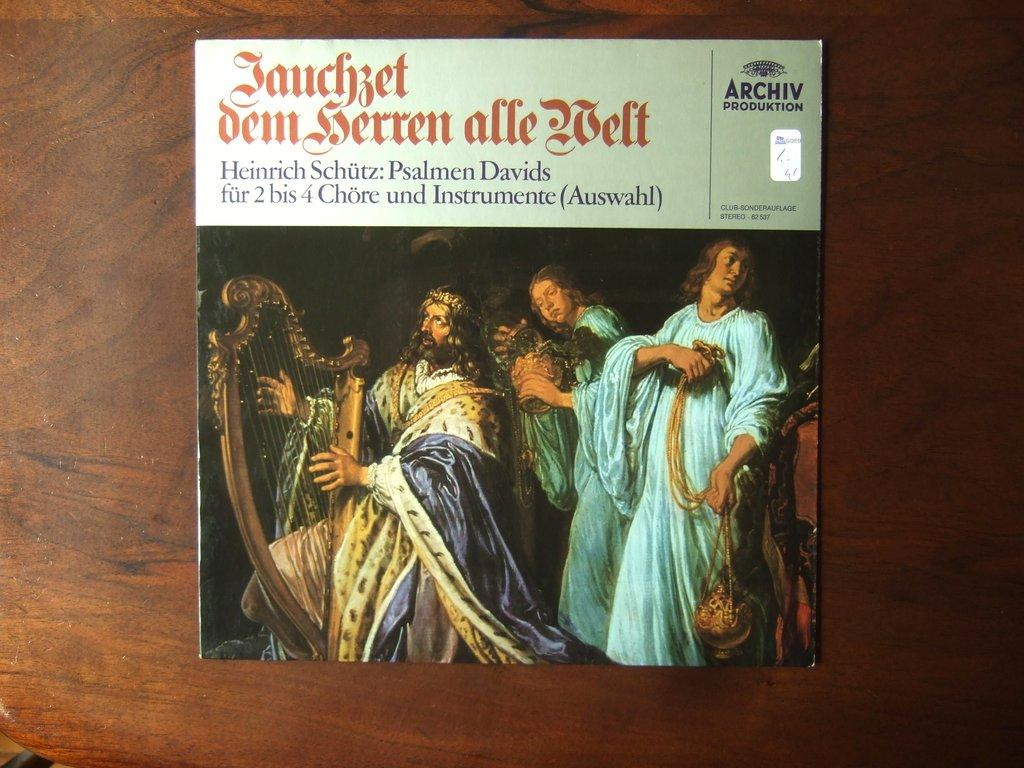What can be seen in the picture besides the people? There is a book in the picture. What are some of the people doing in the picture? Some of the people are playing a musical instrument. Where is the object with the name located? The object with the name is kept on a wooden table. How many roots can be seen growing from the book in the image? There are no roots growing from the book in the image. What color are the eyes of the person playing the musical instrument? There is no mention of the person's eyes in the provided facts, so we cannot determine their color. 